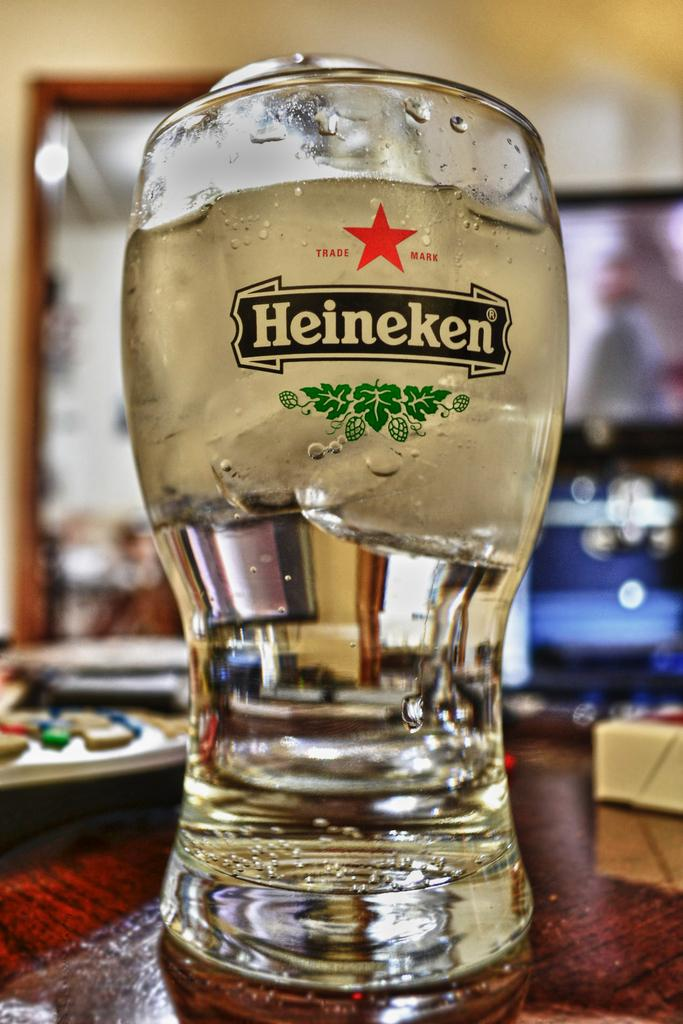Provide a one-sentence caption for the provided image. A Heineken glass is filled with ice cold water. 